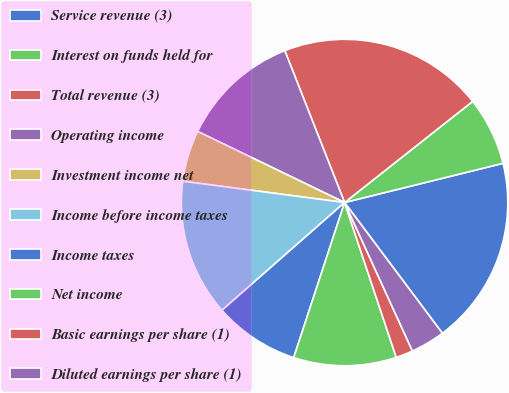<chart> <loc_0><loc_0><loc_500><loc_500><pie_chart><fcel>Service revenue (3)<fcel>Interest on funds held for<fcel>Total revenue (3)<fcel>Operating income<fcel>Investment income net<fcel>Income before income taxes<fcel>Income taxes<fcel>Net income<fcel>Basic earnings per share (1)<fcel>Diluted earnings per share (1)<nl><fcel>18.64%<fcel>6.78%<fcel>20.33%<fcel>11.86%<fcel>5.09%<fcel>13.56%<fcel>8.48%<fcel>10.17%<fcel>1.7%<fcel>3.4%<nl></chart> 